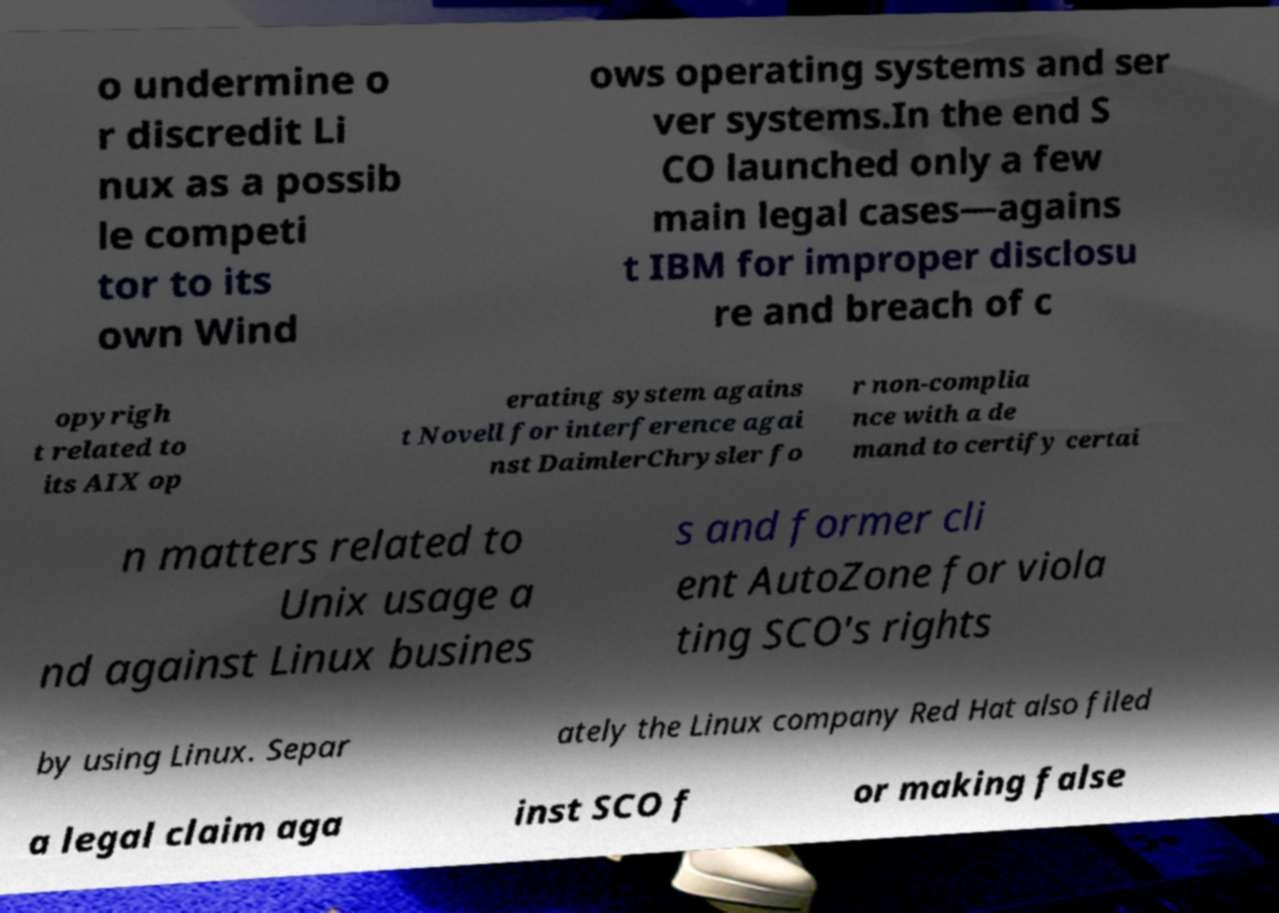Could you assist in decoding the text presented in this image and type it out clearly? o undermine o r discredit Li nux as a possib le competi tor to its own Wind ows operating systems and ser ver systems.In the end S CO launched only a few main legal cases—agains t IBM for improper disclosu re and breach of c opyrigh t related to its AIX op erating system agains t Novell for interference agai nst DaimlerChrysler fo r non-complia nce with a de mand to certify certai n matters related to Unix usage a nd against Linux busines s and former cli ent AutoZone for viola ting SCO's rights by using Linux. Separ ately the Linux company Red Hat also filed a legal claim aga inst SCO f or making false 